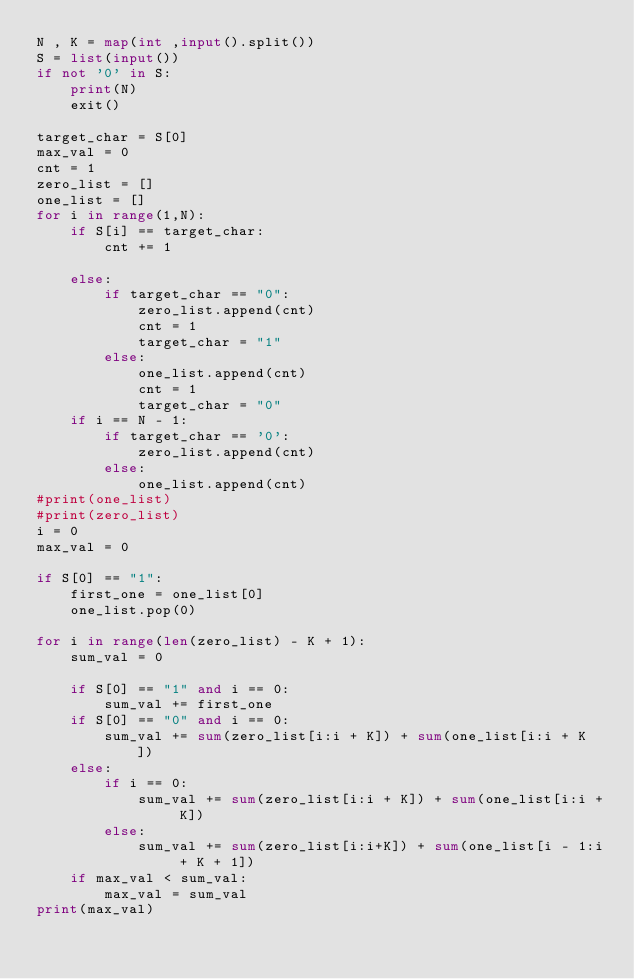<code> <loc_0><loc_0><loc_500><loc_500><_Python_>N , K = map(int ,input().split())
S = list(input())
if not '0' in S:
    print(N)
    exit()

target_char = S[0]
max_val = 0
cnt = 1
zero_list = []
one_list = []
for i in range(1,N):
    if S[i] == target_char:
        cnt += 1

    else:
        if target_char == "0":
            zero_list.append(cnt)
            cnt = 1
            target_char = "1"
        else:
            one_list.append(cnt)
            cnt = 1
            target_char = "0"
    if i == N - 1:
        if target_char == '0':
            zero_list.append(cnt)
        else:
            one_list.append(cnt)
#print(one_list)
#print(zero_list)
i = 0
max_val = 0

if S[0] == "1":
    first_one = one_list[0]
    one_list.pop(0)

for i in range(len(zero_list) - K + 1):
    sum_val = 0

    if S[0] == "1" and i == 0:
        sum_val += first_one
    if S[0] == "0" and i == 0:
        sum_val += sum(zero_list[i:i + K]) + sum(one_list[i:i + K ])
    else:
        if i == 0:
            sum_val += sum(zero_list[i:i + K]) + sum(one_list[i:i + K])
        else:
            sum_val += sum(zero_list[i:i+K]) + sum(one_list[i - 1:i + K + 1])
    if max_val < sum_val:
        max_val = sum_val
print(max_val)</code> 